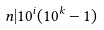<formula> <loc_0><loc_0><loc_500><loc_500>n | 1 0 ^ { i } ( 1 0 ^ { k } - 1 )</formula> 